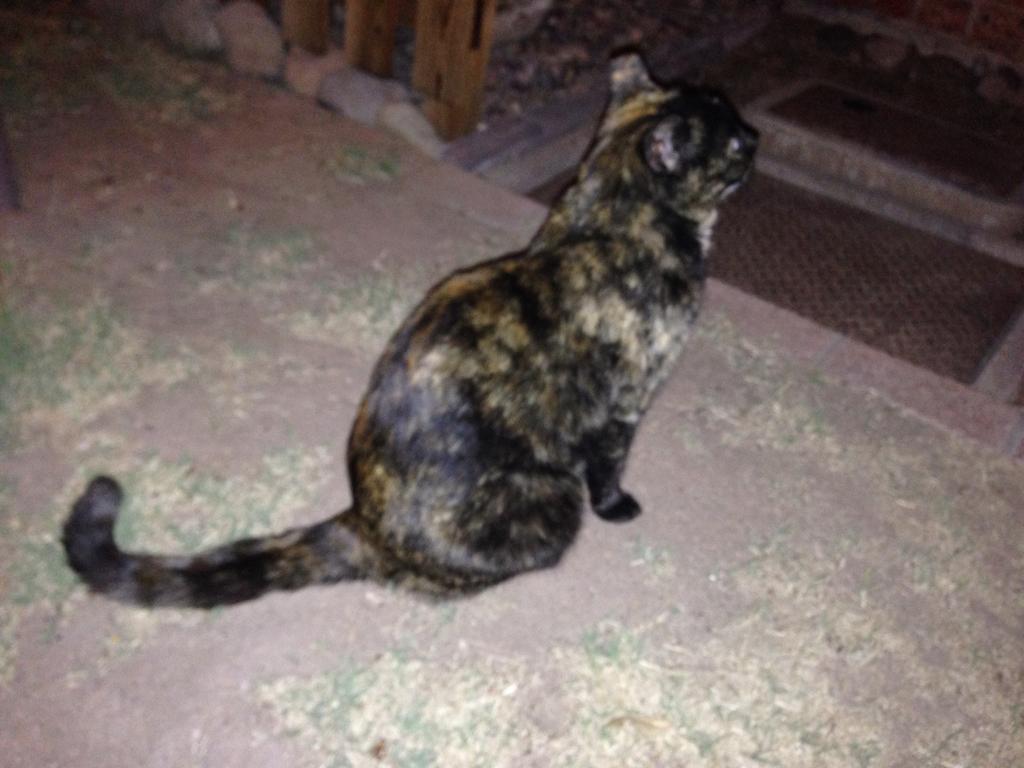Can you describe this image briefly? Here we can see a cat on the ground. There are stones and it might be a grill. 